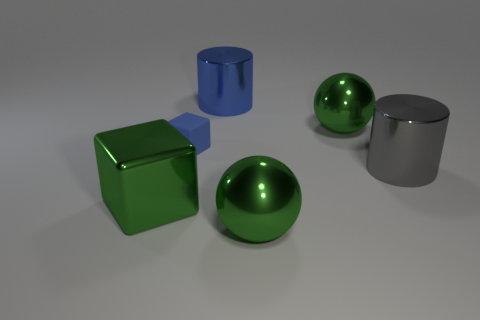Add 1 green blocks. How many objects exist? 7 Subtract all cylinders. How many objects are left? 4 Add 6 cubes. How many cubes are left? 8 Add 6 gray objects. How many gray objects exist? 7 Subtract 1 blue cylinders. How many objects are left? 5 Subtract all small green shiny cubes. Subtract all big spheres. How many objects are left? 4 